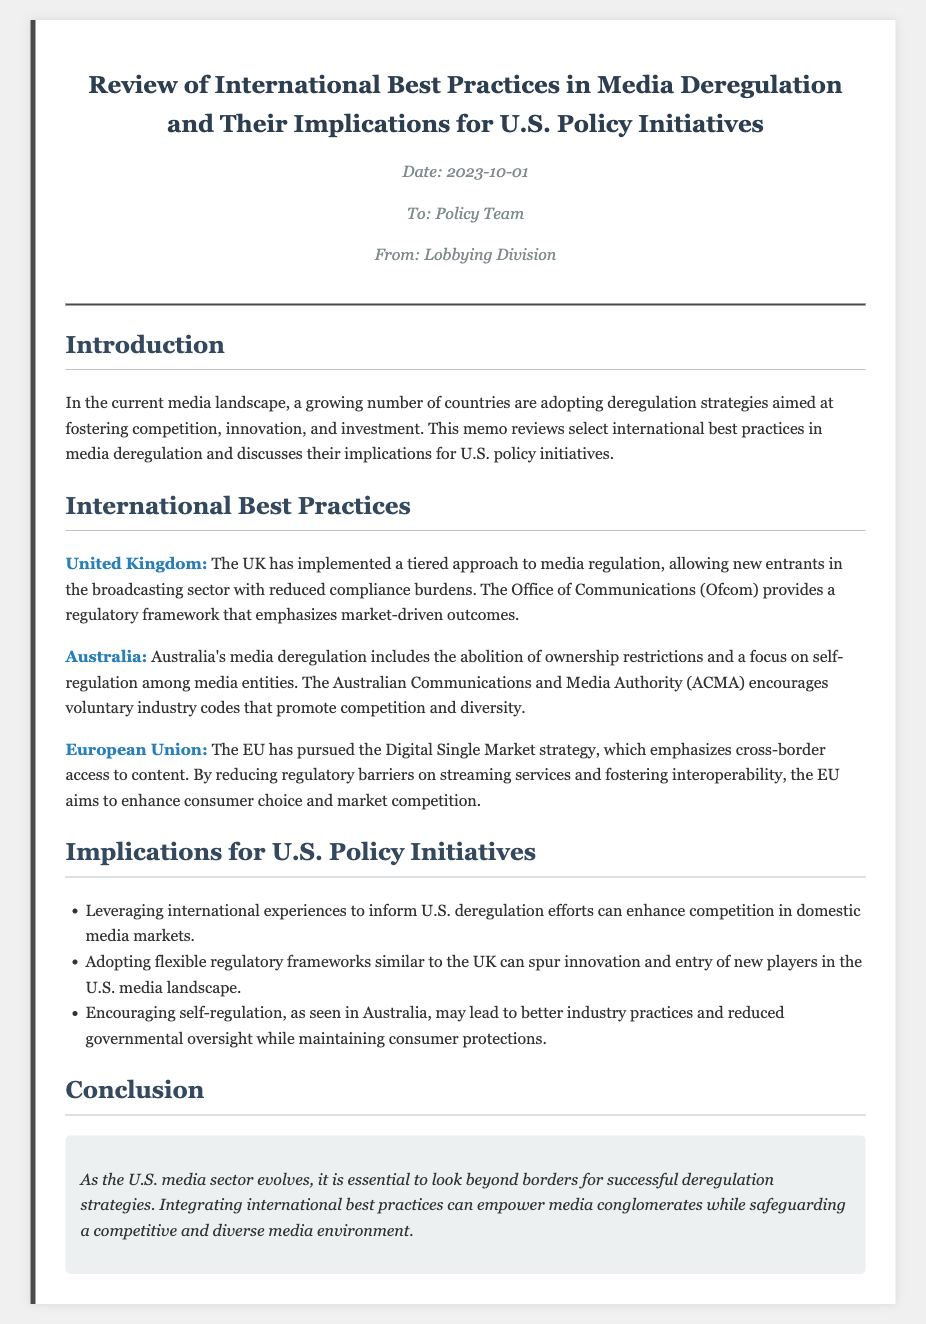what is the title of the memo? The title is the main heading of the document that describes its content, which is "Review of International Best Practices in Media Deregulation and Their Implications for U.S. Policy Initiatives."
Answer: Review of International Best Practices in Media Deregulation and Their Implications for U.S. Policy Initiatives who is the memo addressed to? The memo is directed towards the specific audience indicated in the document, which is the "Policy Team."
Answer: Policy Team what date was the memo issued? The publication date is present in the document's meta section, which is "2023-10-01."
Answer: 2023-10-01 which country is noted for a tiered approach to media regulation? The document mentions the United Kingdom's tiered approach as a key practice in media regulation.
Answer: United Kingdom what does ACMA stand for? ACMA is referred to in the context of media deregulation in Australia, where it stands for "Australian Communications and Media Authority."
Answer: Australian Communications and Media Authority what is the primary strategy pursued by the European Union in media deregulation? The document indicates that the strategy pursued by the EU is the "Digital Single Market."
Answer: Digital Single Market how does the memo suggest the U.S. can enhance competition in media markets? It suggests leveraging international experiences as a means to inform and improve U.S. deregulation efforts.
Answer: Leveraging international experiences what is one implication of adopting a flexible regulatory framework similar to the UK? The document states that it can spur innovation and entry of new players in the U.S. media landscape.
Answer: spur innovation and entry of new players what is emphasized in the conclusion regarding international strategies? The conclusion emphasizes looking beyond borders for successful deregulation strategies.
Answer: looking beyond borders 